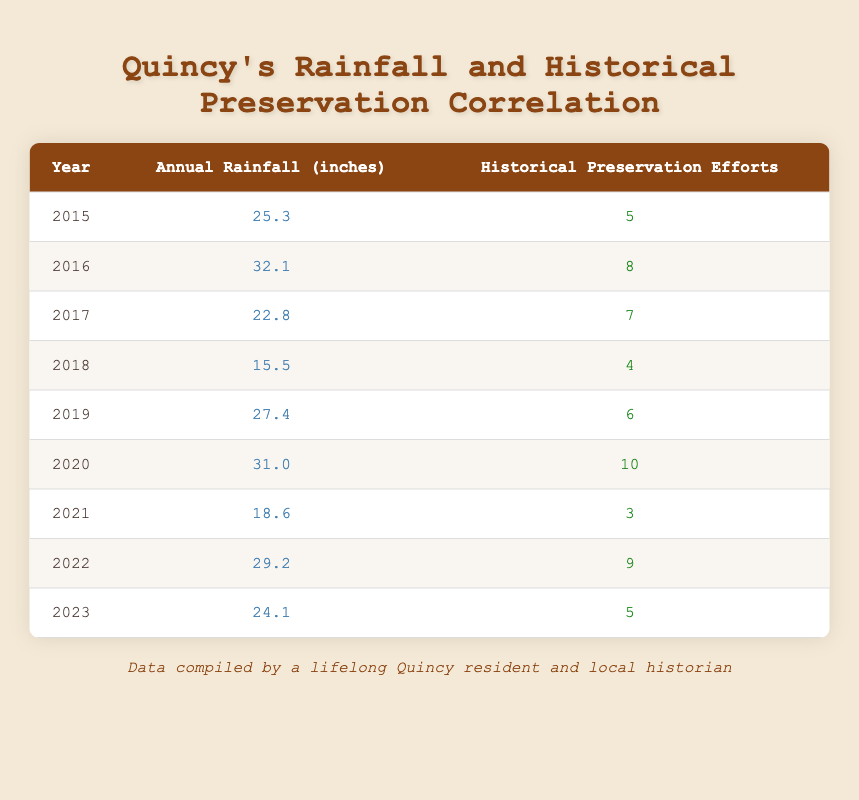What was the highest annual rainfall recorded in Quincy from 2015 to 2023? By examining the annual rainfall column in the table, we see that the highest value is 32.1 inches, which occurred in the year 2016.
Answer: 32.1 inches In which year did Quincy have the lowest number of historical preservation efforts? Looking at the historical preservation efforts column, the lowest value is 3, which occurred in the year 2021.
Answer: 2021 What is the average annual rainfall from 2015 to 2023? To find the average, sum the annual rainfall values: 25.3 + 32.1 + 22.8 + 15.5 + 27.4 + 31.0 + 18.6 + 29.2 + 24.1 =  205.0 inches. There are 9 data points, so the average is 205.0 / 9 = 22.78 inches.
Answer: 22.78 inches Did historical preservation efforts increase from 2018 to 2020? In 2018, there were 4 efforts, and in 2020, there were 10 efforts. Comparing these values, we see that 10 is greater than 4, indicating an increase.
Answer: Yes What was the total number of historical preservation efforts from 2015 to 2023? By summing the historical preservation efforts: 5 + 8 + 7 + 4 + 6 + 10 + 3 + 9 + 5 = 57. Therefore, the total is 57 efforts.
Answer: 57 efforts In which years did Quincy have annual rainfall above 30 inches? Looking at the rainfall data, the years with values above 30 inches are 2016 (32.1 inches) and 2020 (31.0 inches). Both years exceed 30 inches.
Answer: 2016 and 2020 Is it true that there were more historical preservation efforts in 2022 than in 2019? In 2022, there were 9 efforts, while in 2019 there were 6 efforts. Since 9 is greater than 6, the statement is true.
Answer: Yes Which year had a higher annual rainfall, 2015 or 2019? Comparing the annual rainfall for both years: 2015 had 25.3 inches, while 2019 had 27.4 inches. Since 27.4 inches is greater than 25.3 inches, 2019 had a higher rainfall.
Answer: 2019 What is the difference in historical preservation efforts between 2020 and 2021? The efforts in 2020 amounted to 10, while in 2021 there were 3 efforts. Calculating the difference: 10 - 3 = 7.
Answer: 7 efforts 